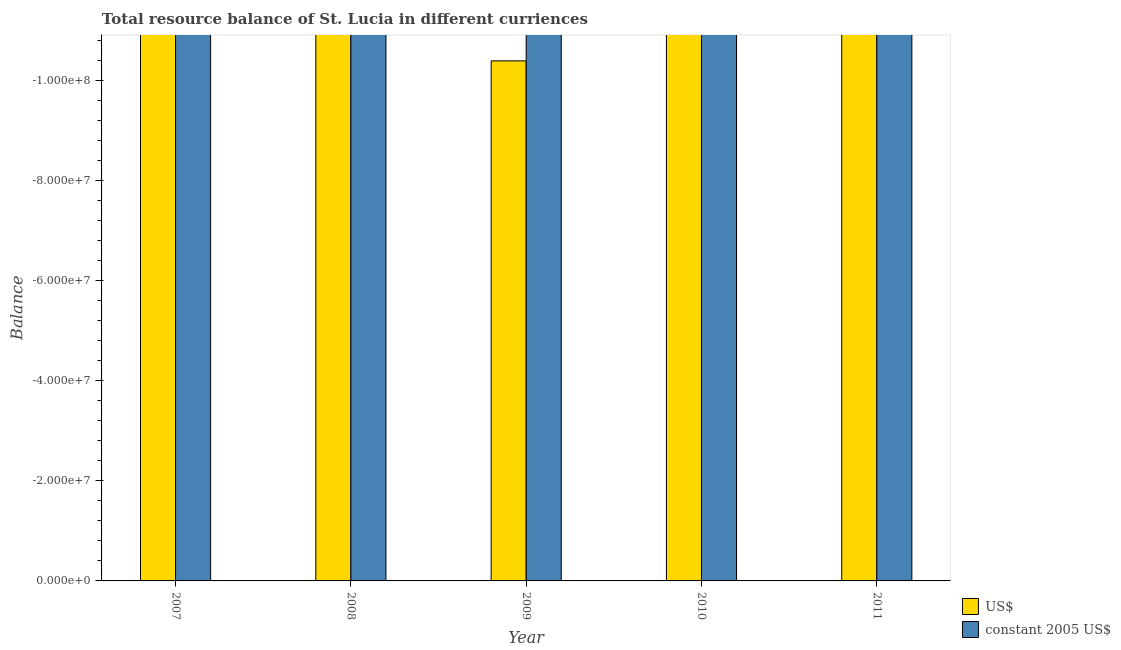How many different coloured bars are there?
Provide a short and direct response. 0. Are the number of bars per tick equal to the number of legend labels?
Offer a terse response. No. In how many cases, is the number of bars for a given year not equal to the number of legend labels?
Provide a succinct answer. 5. What is the difference between the resource balance in us$ in 2009 and the resource balance in constant us$ in 2010?
Offer a terse response. 0. How many bars are there?
Keep it short and to the point. 0. Are all the bars in the graph horizontal?
Offer a terse response. No. How many years are there in the graph?
Make the answer very short. 5. What is the difference between two consecutive major ticks on the Y-axis?
Ensure brevity in your answer.  2.00e+07. Are the values on the major ticks of Y-axis written in scientific E-notation?
Your response must be concise. Yes. How many legend labels are there?
Your answer should be very brief. 2. How are the legend labels stacked?
Offer a terse response. Vertical. What is the title of the graph?
Your answer should be very brief. Total resource balance of St. Lucia in different curriences. What is the label or title of the X-axis?
Keep it short and to the point. Year. What is the label or title of the Y-axis?
Your response must be concise. Balance. What is the Balance of constant 2005 US$ in 2007?
Make the answer very short. 0. What is the Balance of US$ in 2008?
Keep it short and to the point. 0. What is the Balance in constant 2005 US$ in 2008?
Your answer should be very brief. 0. What is the Balance of US$ in 2009?
Your response must be concise. 0. What is the Balance of US$ in 2010?
Give a very brief answer. 0. What is the Balance in constant 2005 US$ in 2010?
Give a very brief answer. 0. What is the Balance in US$ in 2011?
Provide a succinct answer. 0. What is the Balance in constant 2005 US$ in 2011?
Offer a very short reply. 0. What is the total Balance of US$ in the graph?
Offer a very short reply. 0. What is the total Balance of constant 2005 US$ in the graph?
Provide a succinct answer. 0. What is the average Balance of constant 2005 US$ per year?
Offer a very short reply. 0. 